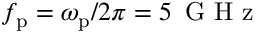<formula> <loc_0><loc_0><loc_500><loc_500>f _ { p } = \omega _ { p } / 2 \pi = 5 \, G H z</formula> 